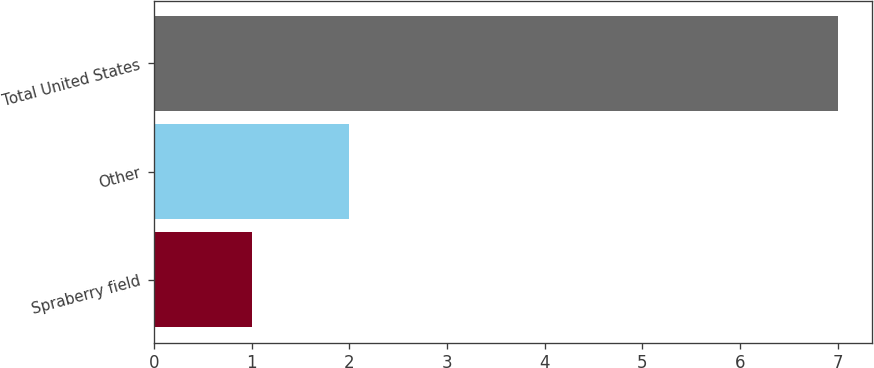Convert chart to OTSL. <chart><loc_0><loc_0><loc_500><loc_500><bar_chart><fcel>Spraberry field<fcel>Other<fcel>Total United States<nl><fcel>1<fcel>2<fcel>7<nl></chart> 